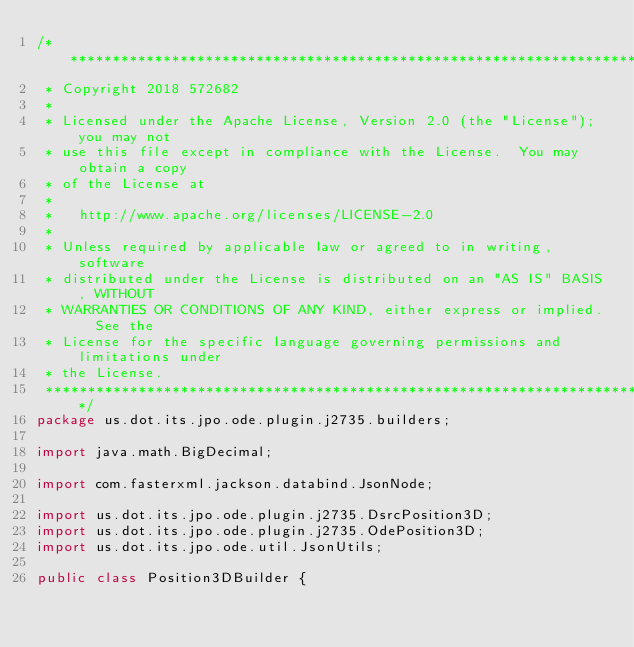Convert code to text. <code><loc_0><loc_0><loc_500><loc_500><_Java_>/*******************************************************************************
 * Copyright 2018 572682
 * 
 * Licensed under the Apache License, Version 2.0 (the "License"); you may not
 * use this file except in compliance with the License.  You may obtain a copy
 * of the License at
 * 
 *   http://www.apache.org/licenses/LICENSE-2.0
 * 
 * Unless required by applicable law or agreed to in writing, software
 * distributed under the License is distributed on an "AS IS" BASIS, WITHOUT
 * WARRANTIES OR CONDITIONS OF ANY KIND, either express or implied.  See the
 * License for the specific language governing permissions and limitations under
 * the License.
 ******************************************************************************/
package us.dot.its.jpo.ode.plugin.j2735.builders;

import java.math.BigDecimal;

import com.fasterxml.jackson.databind.JsonNode;

import us.dot.its.jpo.ode.plugin.j2735.DsrcPosition3D;
import us.dot.its.jpo.ode.plugin.j2735.OdePosition3D;
import us.dot.its.jpo.ode.util.JsonUtils;

public class Position3DBuilder {
   </code> 